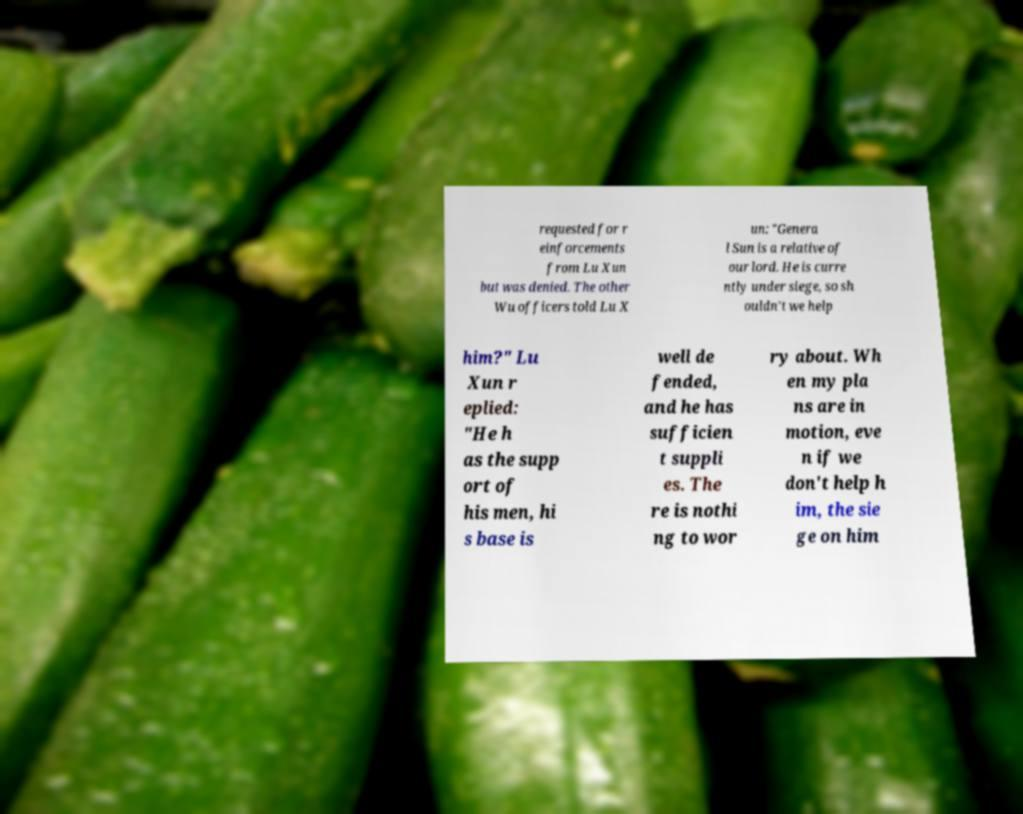Can you read and provide the text displayed in the image?This photo seems to have some interesting text. Can you extract and type it out for me? requested for r einforcements from Lu Xun but was denied. The other Wu officers told Lu X un: "Genera l Sun is a relative of our lord. He is curre ntly under siege, so sh ouldn't we help him?" Lu Xun r eplied: "He h as the supp ort of his men, hi s base is well de fended, and he has sufficien t suppli es. The re is nothi ng to wor ry about. Wh en my pla ns are in motion, eve n if we don't help h im, the sie ge on him 